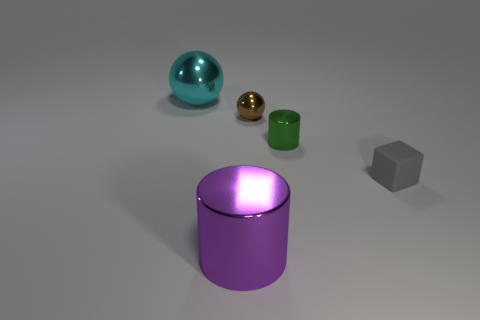What time of day does the lighting in this image suggest? The image seems to have a neutral and diffuse lighting without strong shadows, which doesn't clearly suggest a specific time of day. It appears artificial, as if set in a controlled indoor environment like a photography studio. 